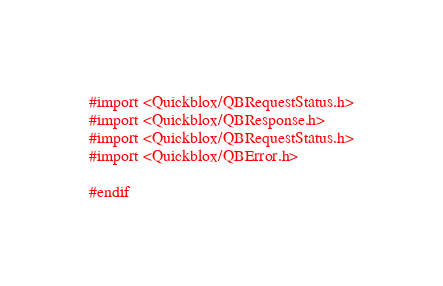<code> <loc_0><loc_0><loc_500><loc_500><_C_>#import <Quickblox/QBRequestStatus.h>
#import <Quickblox/QBResponse.h>
#import <Quickblox/QBRequestStatus.h>
#import <Quickblox/QBError.h>

#endif
</code> 